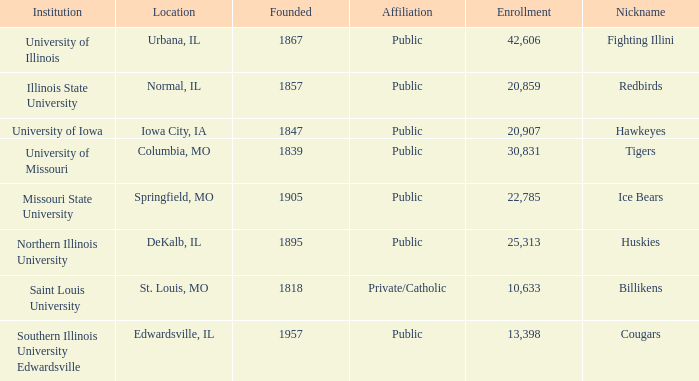What is southern illinois university edwardsville's association? Public. 